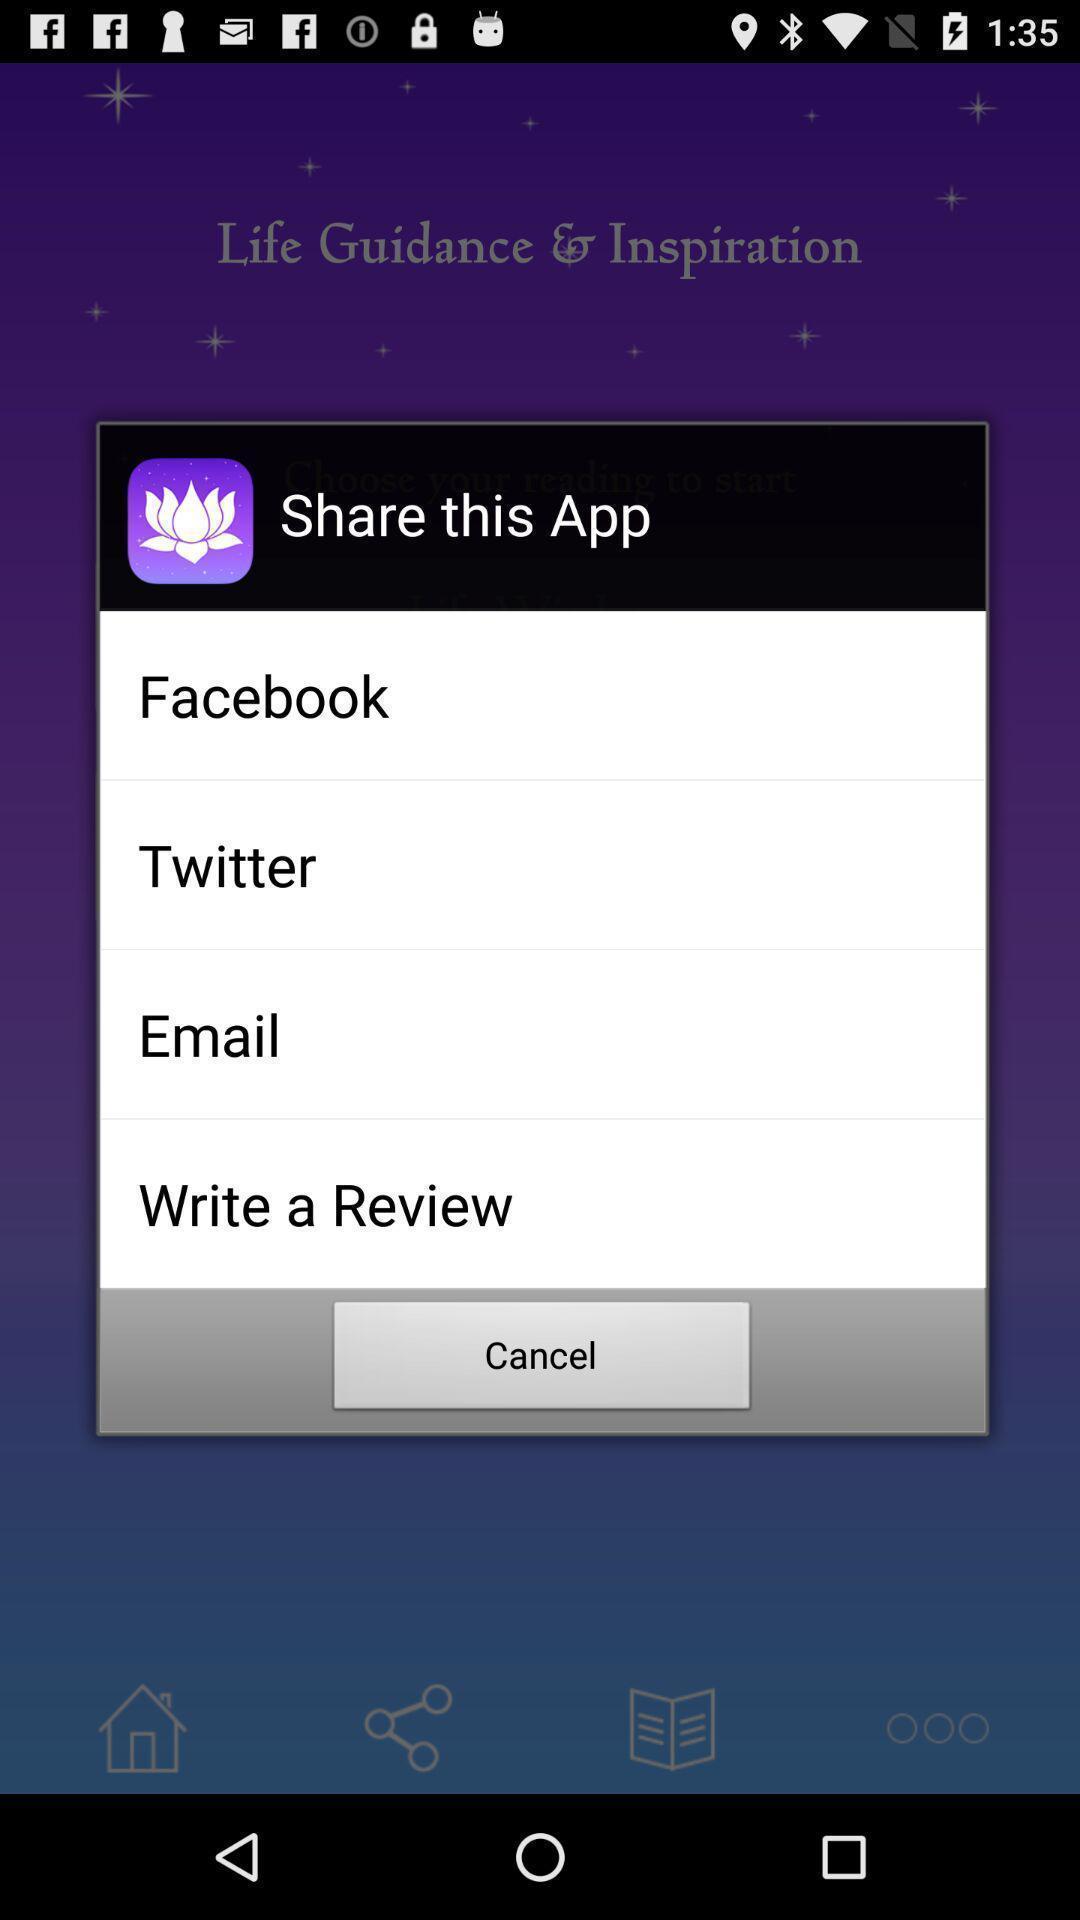Summarize the information in this screenshot. Screen displaying sharing options using different social applications. 